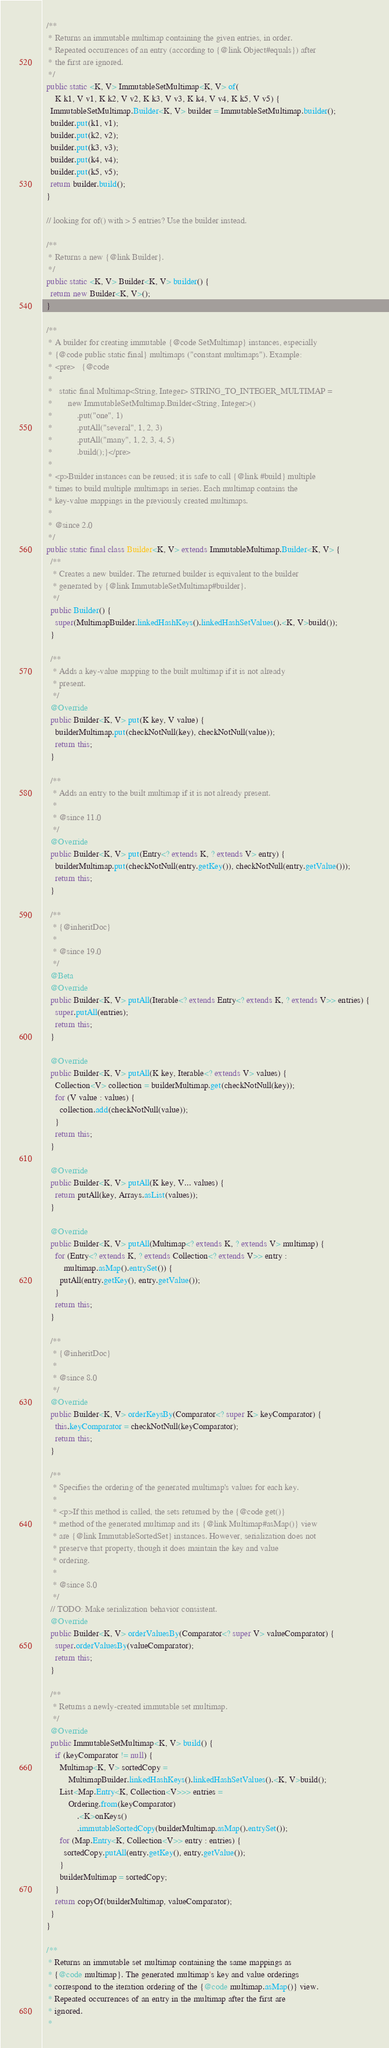Convert code to text. <code><loc_0><loc_0><loc_500><loc_500><_Java_>  /**
   * Returns an immutable multimap containing the given entries, in order.
   * Repeated occurrences of an entry (according to {@link Object#equals}) after
   * the first are ignored.
   */
  public static <K, V> ImmutableSetMultimap<K, V> of(
      K k1, V v1, K k2, V v2, K k3, V v3, K k4, V v4, K k5, V v5) {
    ImmutableSetMultimap.Builder<K, V> builder = ImmutableSetMultimap.builder();
    builder.put(k1, v1);
    builder.put(k2, v2);
    builder.put(k3, v3);
    builder.put(k4, v4);
    builder.put(k5, v5);
    return builder.build();
  }

  // looking for of() with > 5 entries? Use the builder instead.

  /**
   * Returns a new {@link Builder}.
   */
  public static <K, V> Builder<K, V> builder() {
    return new Builder<K, V>();
  }

  /**
   * A builder for creating immutable {@code SetMultimap} instances, especially
   * {@code public static final} multimaps ("constant multimaps"). Example:
   * <pre>   {@code
   *
   *   static final Multimap<String, Integer> STRING_TO_INTEGER_MULTIMAP =
   *       new ImmutableSetMultimap.Builder<String, Integer>()
   *           .put("one", 1)
   *           .putAll("several", 1, 2, 3)
   *           .putAll("many", 1, 2, 3, 4, 5)
   *           .build();}</pre>
   *
   * <p>Builder instances can be reused; it is safe to call {@link #build} multiple
   * times to build multiple multimaps in series. Each multimap contains the
   * key-value mappings in the previously created multimaps.
   *
   * @since 2.0
   */
  public static final class Builder<K, V> extends ImmutableMultimap.Builder<K, V> {
    /**
     * Creates a new builder. The returned builder is equivalent to the builder
     * generated by {@link ImmutableSetMultimap#builder}.
     */
    public Builder() {
      super(MultimapBuilder.linkedHashKeys().linkedHashSetValues().<K, V>build());
    }

    /**
     * Adds a key-value mapping to the built multimap if it is not already
     * present.
     */
    @Override
    public Builder<K, V> put(K key, V value) {
      builderMultimap.put(checkNotNull(key), checkNotNull(value));
      return this;
    }

    /**
     * Adds an entry to the built multimap if it is not already present.
     *
     * @since 11.0
     */
    @Override
    public Builder<K, V> put(Entry<? extends K, ? extends V> entry) {
      builderMultimap.put(checkNotNull(entry.getKey()), checkNotNull(entry.getValue()));
      return this;
    }

    /**
     * {@inheritDoc}
     *
     * @since 19.0
     */
    @Beta
    @Override
    public Builder<K, V> putAll(Iterable<? extends Entry<? extends K, ? extends V>> entries) {
      super.putAll(entries);
      return this;
    }

    @Override
    public Builder<K, V> putAll(K key, Iterable<? extends V> values) {
      Collection<V> collection = builderMultimap.get(checkNotNull(key));
      for (V value : values) {
        collection.add(checkNotNull(value));
      }
      return this;
    }

    @Override
    public Builder<K, V> putAll(K key, V... values) {
      return putAll(key, Arrays.asList(values));
    }

    @Override
    public Builder<K, V> putAll(Multimap<? extends K, ? extends V> multimap) {
      for (Entry<? extends K, ? extends Collection<? extends V>> entry :
          multimap.asMap().entrySet()) {
        putAll(entry.getKey(), entry.getValue());
      }
      return this;
    }

    /**
     * {@inheritDoc}
     *
     * @since 8.0
     */
    @Override
    public Builder<K, V> orderKeysBy(Comparator<? super K> keyComparator) {
      this.keyComparator = checkNotNull(keyComparator);
      return this;
    }

    /**
     * Specifies the ordering of the generated multimap's values for each key.
     *
     * <p>If this method is called, the sets returned by the {@code get()}
     * method of the generated multimap and its {@link Multimap#asMap()} view
     * are {@link ImmutableSortedSet} instances. However, serialization does not
     * preserve that property, though it does maintain the key and value
     * ordering.
     *
     * @since 8.0
     */
    // TODO: Make serialization behavior consistent.
    @Override
    public Builder<K, V> orderValuesBy(Comparator<? super V> valueComparator) {
      super.orderValuesBy(valueComparator);
      return this;
    }

    /**
     * Returns a newly-created immutable set multimap.
     */
    @Override
    public ImmutableSetMultimap<K, V> build() {
      if (keyComparator != null) {
        Multimap<K, V> sortedCopy =
            MultimapBuilder.linkedHashKeys().linkedHashSetValues().<K, V>build();
        List<Map.Entry<K, Collection<V>>> entries =
            Ordering.from(keyComparator)
                .<K>onKeys()
                .immutableSortedCopy(builderMultimap.asMap().entrySet());
        for (Map.Entry<K, Collection<V>> entry : entries) {
          sortedCopy.putAll(entry.getKey(), entry.getValue());
        }
        builderMultimap = sortedCopy;
      }
      return copyOf(builderMultimap, valueComparator);
    }
  }

  /**
   * Returns an immutable set multimap containing the same mappings as
   * {@code multimap}. The generated multimap's key and value orderings
   * correspond to the iteration ordering of the {@code multimap.asMap()} view.
   * Repeated occurrences of an entry in the multimap after the first are
   * ignored.
   *</code> 